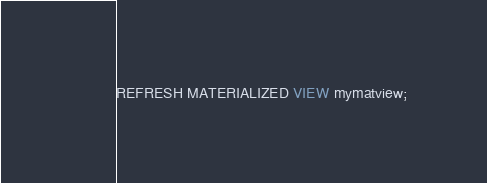Convert code to text. <code><loc_0><loc_0><loc_500><loc_500><_SQL_>REFRESH MATERIALIZED VIEW mymatview;
</code> 